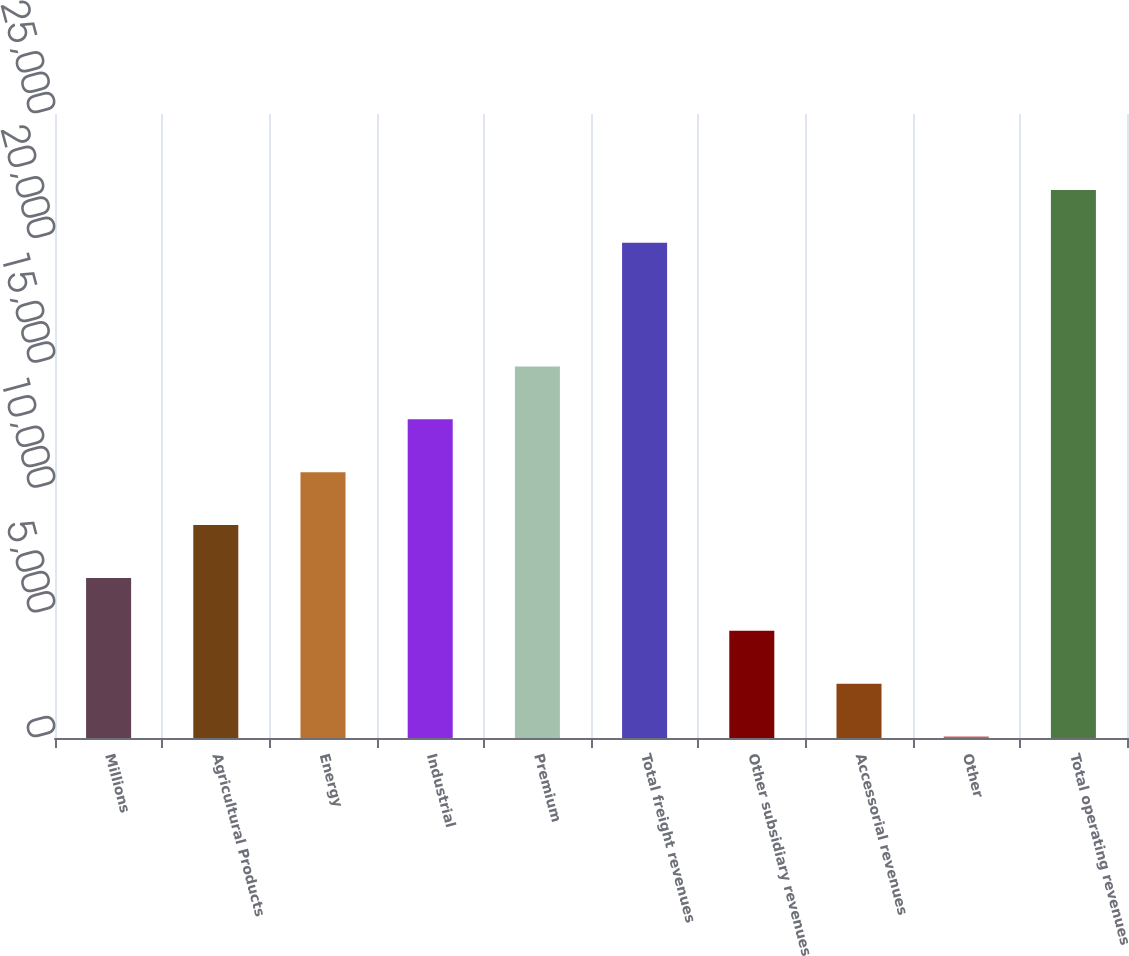<chart> <loc_0><loc_0><loc_500><loc_500><bar_chart><fcel>Millions<fcel>Agricultural Products<fcel>Energy<fcel>Industrial<fcel>Premium<fcel>Total freight revenues<fcel>Other subsidiary revenues<fcel>Accessorial revenues<fcel>Other<fcel>Total operating revenues<nl><fcel>6414<fcel>8532<fcel>10650<fcel>12768<fcel>14886<fcel>19837<fcel>4296<fcel>2178<fcel>60<fcel>21955<nl></chart> 